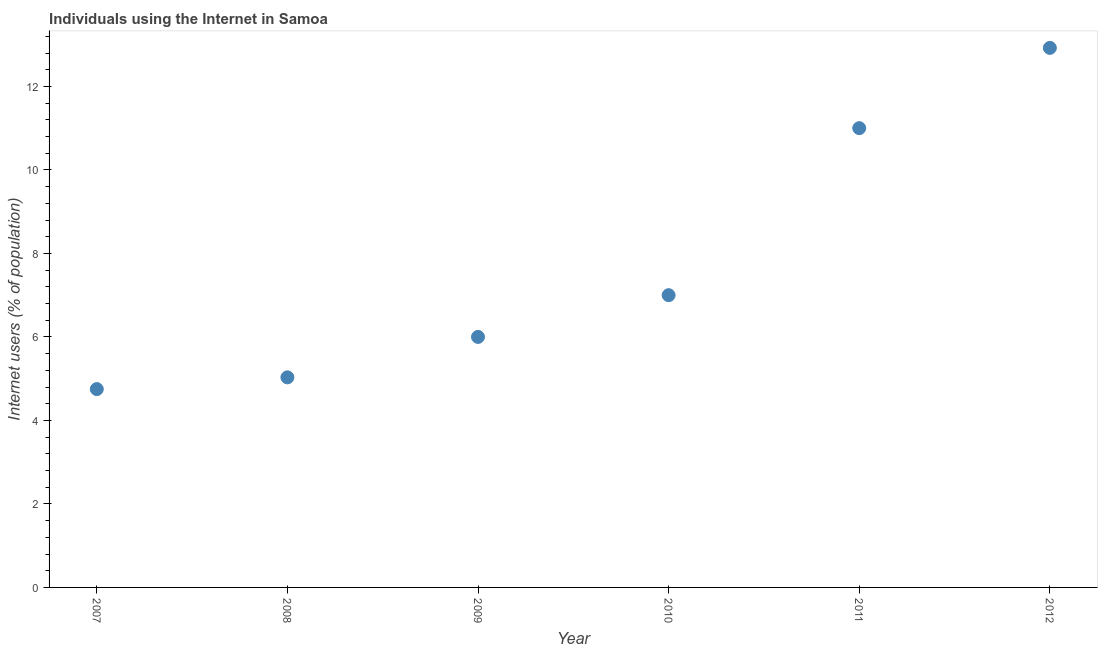Across all years, what is the maximum number of internet users?
Make the answer very short. 12.92. Across all years, what is the minimum number of internet users?
Your response must be concise. 4.75. In which year was the number of internet users maximum?
Provide a succinct answer. 2012. In which year was the number of internet users minimum?
Provide a short and direct response. 2007. What is the sum of the number of internet users?
Offer a very short reply. 46.7. What is the average number of internet users per year?
Provide a succinct answer. 7.78. In how many years, is the number of internet users greater than 7.2 %?
Offer a very short reply. 2. What is the ratio of the number of internet users in 2008 to that in 2012?
Your answer should be compact. 0.39. Is the difference between the number of internet users in 2009 and 2012 greater than the difference between any two years?
Offer a very short reply. No. What is the difference between the highest and the second highest number of internet users?
Keep it short and to the point. 1.92. Is the sum of the number of internet users in 2009 and 2010 greater than the maximum number of internet users across all years?
Keep it short and to the point. Yes. What is the difference between the highest and the lowest number of internet users?
Offer a very short reply. 8.17. Does the number of internet users monotonically increase over the years?
Your answer should be very brief. Yes. How many dotlines are there?
Keep it short and to the point. 1. How many years are there in the graph?
Provide a succinct answer. 6. Are the values on the major ticks of Y-axis written in scientific E-notation?
Provide a short and direct response. No. What is the title of the graph?
Your response must be concise. Individuals using the Internet in Samoa. What is the label or title of the X-axis?
Your answer should be compact. Year. What is the label or title of the Y-axis?
Provide a succinct answer. Internet users (% of population). What is the Internet users (% of population) in 2007?
Your response must be concise. 4.75. What is the Internet users (% of population) in 2008?
Provide a short and direct response. 5.03. What is the Internet users (% of population) in 2009?
Your response must be concise. 6. What is the Internet users (% of population) in 2012?
Offer a very short reply. 12.92. What is the difference between the Internet users (% of population) in 2007 and 2008?
Offer a terse response. -0.28. What is the difference between the Internet users (% of population) in 2007 and 2009?
Offer a terse response. -1.25. What is the difference between the Internet users (% of population) in 2007 and 2010?
Provide a short and direct response. -2.25. What is the difference between the Internet users (% of population) in 2007 and 2011?
Offer a very short reply. -6.25. What is the difference between the Internet users (% of population) in 2007 and 2012?
Make the answer very short. -8.17. What is the difference between the Internet users (% of population) in 2008 and 2009?
Provide a short and direct response. -0.97. What is the difference between the Internet users (% of population) in 2008 and 2010?
Give a very brief answer. -1.97. What is the difference between the Internet users (% of population) in 2008 and 2011?
Give a very brief answer. -5.97. What is the difference between the Internet users (% of population) in 2008 and 2012?
Offer a very short reply. -7.89. What is the difference between the Internet users (% of population) in 2009 and 2011?
Give a very brief answer. -5. What is the difference between the Internet users (% of population) in 2009 and 2012?
Your answer should be compact. -6.92. What is the difference between the Internet users (% of population) in 2010 and 2011?
Your response must be concise. -4. What is the difference between the Internet users (% of population) in 2010 and 2012?
Keep it short and to the point. -5.92. What is the difference between the Internet users (% of population) in 2011 and 2012?
Keep it short and to the point. -1.92. What is the ratio of the Internet users (% of population) in 2007 to that in 2008?
Your answer should be very brief. 0.94. What is the ratio of the Internet users (% of population) in 2007 to that in 2009?
Give a very brief answer. 0.79. What is the ratio of the Internet users (% of population) in 2007 to that in 2010?
Offer a terse response. 0.68. What is the ratio of the Internet users (% of population) in 2007 to that in 2011?
Give a very brief answer. 0.43. What is the ratio of the Internet users (% of population) in 2007 to that in 2012?
Offer a very short reply. 0.37. What is the ratio of the Internet users (% of population) in 2008 to that in 2009?
Offer a very short reply. 0.84. What is the ratio of the Internet users (% of population) in 2008 to that in 2010?
Ensure brevity in your answer.  0.72. What is the ratio of the Internet users (% of population) in 2008 to that in 2011?
Ensure brevity in your answer.  0.46. What is the ratio of the Internet users (% of population) in 2008 to that in 2012?
Offer a very short reply. 0.39. What is the ratio of the Internet users (% of population) in 2009 to that in 2010?
Give a very brief answer. 0.86. What is the ratio of the Internet users (% of population) in 2009 to that in 2011?
Keep it short and to the point. 0.55. What is the ratio of the Internet users (% of population) in 2009 to that in 2012?
Keep it short and to the point. 0.46. What is the ratio of the Internet users (% of population) in 2010 to that in 2011?
Provide a short and direct response. 0.64. What is the ratio of the Internet users (% of population) in 2010 to that in 2012?
Keep it short and to the point. 0.54. What is the ratio of the Internet users (% of population) in 2011 to that in 2012?
Your response must be concise. 0.85. 